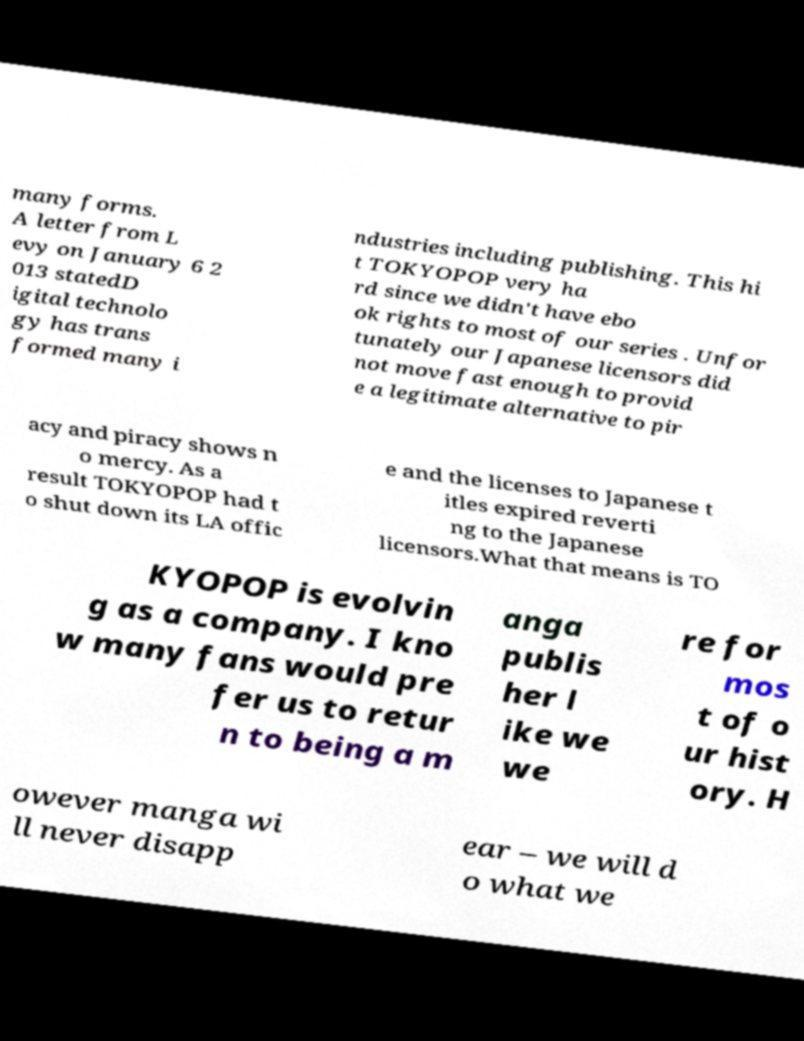What messages or text are displayed in this image? I need them in a readable, typed format. many forms. A letter from L evy on January 6 2 013 statedD igital technolo gy has trans formed many i ndustries including publishing. This hi t TOKYOPOP very ha rd since we didn't have ebo ok rights to most of our series . Unfor tunately our Japanese licensors did not move fast enough to provid e a legitimate alternative to pir acy and piracy shows n o mercy. As a result TOKYOPOP had t o shut down its LA offic e and the licenses to Japanese t itles expired reverti ng to the Japanese licensors.What that means is TO KYOPOP is evolvin g as a company. I kno w many fans would pre fer us to retur n to being a m anga publis her l ike we we re for mos t of o ur hist ory. H owever manga wi ll never disapp ear – we will d o what we 